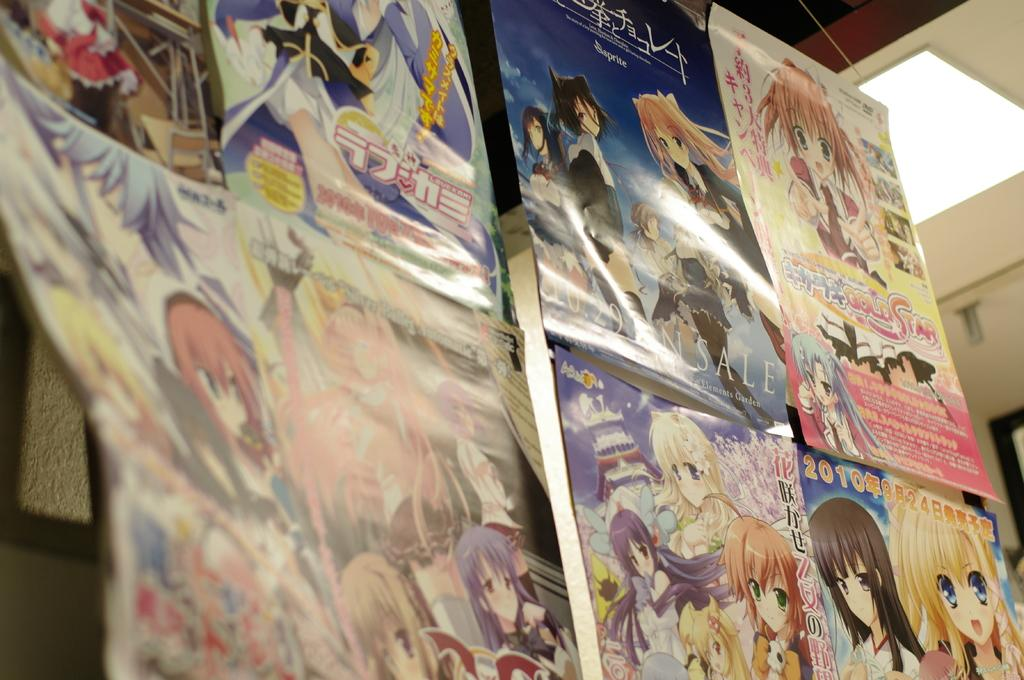<image>
Write a terse but informative summary of the picture. A collection of anime posters including one with the words "gold star" on it. 